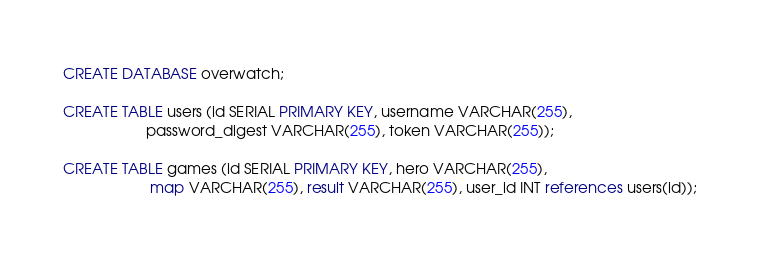<code> <loc_0><loc_0><loc_500><loc_500><_SQL_>CREATE DATABASE overwatch;

CREATE TABLE users (id SERIAL PRIMARY KEY, username VARCHAR(255), 
					password_digest VARCHAR(255), token VARCHAR(255));

CREATE TABLE games (id SERIAL PRIMARY KEY, hero VARCHAR(255),
					 map VARCHAR(255), result VARCHAR(255), user_id INT references users(id));</code> 